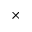Convert formula to latex. <formula><loc_0><loc_0><loc_500><loc_500>\times</formula> 